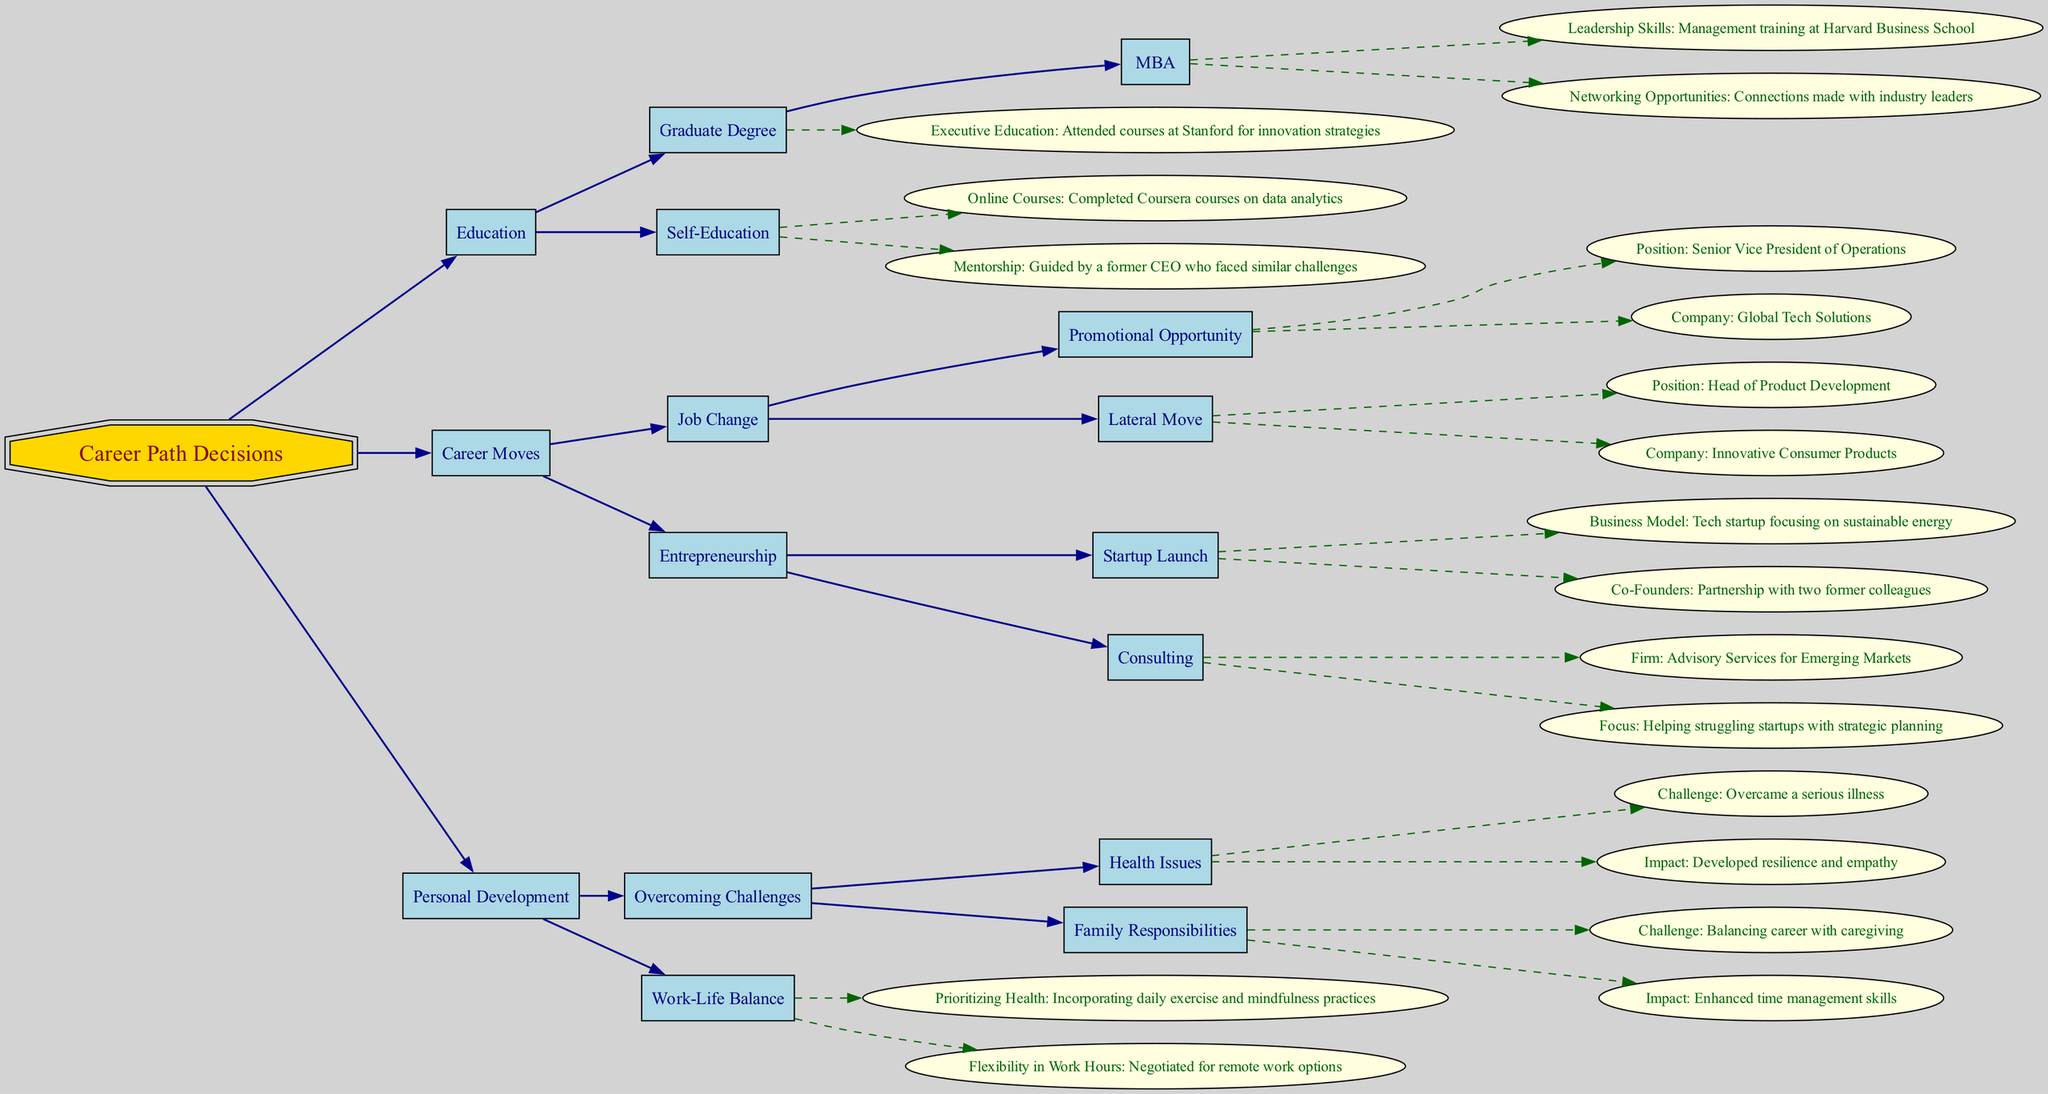What is the highest level in the decision tree? The highest level in the decision tree is labeled "Career Path Decisions," which serves as the root node from which all other nodes branch out.
Answer: Career Path Decisions How many major categories are in the career path decisions? The diagram includes three major categories under career path decisions: Education, Career Moves, and Personal Development, which directly connect to the root node.
Answer: 3 What is one benefit of obtaining a graduate degree? The diagram states that one benefit of obtaining a graduate degree is "Leadership Skills," specifically mentioning management training at Harvard Business School.
Answer: Leadership Skills Which company is associated with the position "Senior Vice President of Operations"? The position "Senior Vice President of Operations" is linked to the company "Global Tech Solutions," indicating where this promotional opportunity is available.
Answer: Global Tech Solutions What personal challenge is mentioned under "Overcoming Challenges"? The diagram highlights "Health Issues" as a personal challenge, showcasing how the corporate leader overcame a serious illness, leading to personal growth.
Answer: Health Issues Which educational path involves mentorship? The educational path that involves mentorship is "Self-Education," specifically illustrating that the corporate leader was guided by a former CEO who faced similar challenges.
Answer: Mentorship What type of business model did the tech startup focus on? According to the diagram, the tech startup focused on a business model related to "sustainable energy," demonstrating the entrepreneurial direction of the corporate leader.
Answer: Sustainable energy How did the leader enhance their time management skills? The leader enhanced their time management skills by balancing career with caregiving, which is mentioned under personal development as a significant personal challenge they faced.
Answer: Balancing career with caregiving What does the diagram specify as a component of "Work-Life Balance"? One specified component of "Work-Life Balance" in the diagram is "Prioritizing Health," which includes practices like daily exercise and mindfulness routines to maintain well-being amidst corporate responsibilities.
Answer: Prioritizing Health 